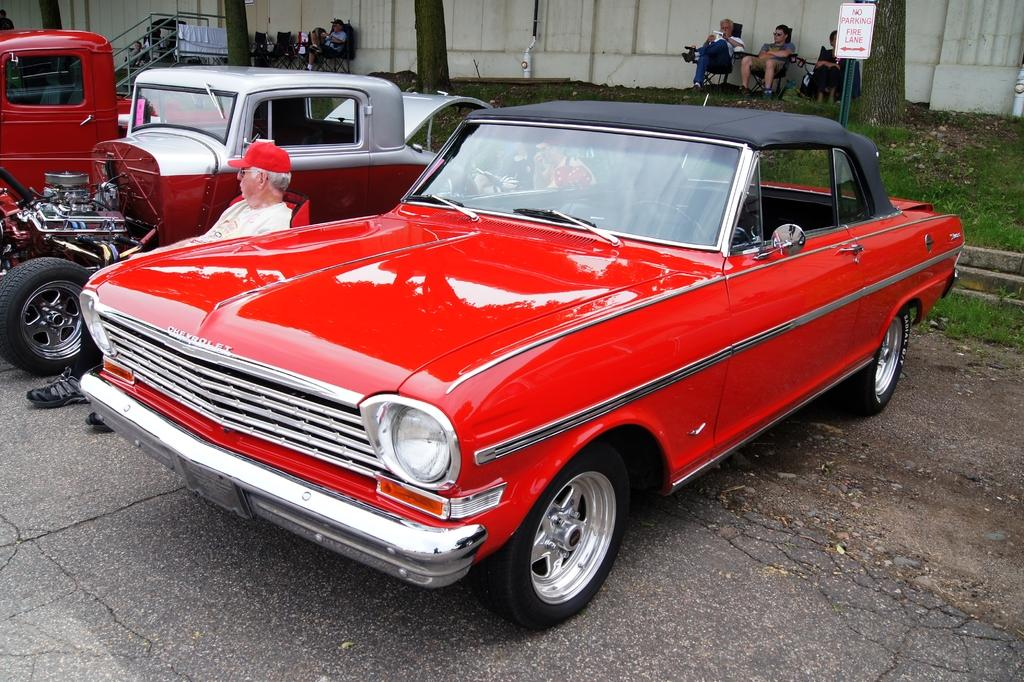What are the people in the image doing? The people in the image are sitting on chairs. What can be seen on the road in the image? There are vehicles on the road in the image. What type of vegetation is visible in the image? Grass is visible in the image. What architectural feature can be seen in the image? There is a railing in the image. What is the background of the image made of? There is a wall in the image. What part of a tree is present in the image? Tree trunks are present in the image. What type of fan is being used by the people sitting on chairs in the image? There is no fan present in the image; the people are sitting on chairs without any visible fans. 